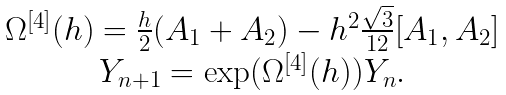Convert formula to latex. <formula><loc_0><loc_0><loc_500><loc_500>\begin{array} { c c c } & \Omega ^ { [ 4 ] } ( h ) = \frac { h } { 2 } ( A _ { 1 } + A _ { 2 } ) - h ^ { 2 } \frac { \sqrt { 3 } } { 1 2 } [ A _ { 1 } , A _ { 2 } ] & \\ & Y _ { n + 1 } = \exp ( \Omega ^ { [ 4 ] } ( h ) ) Y _ { n } . \end{array}</formula> 